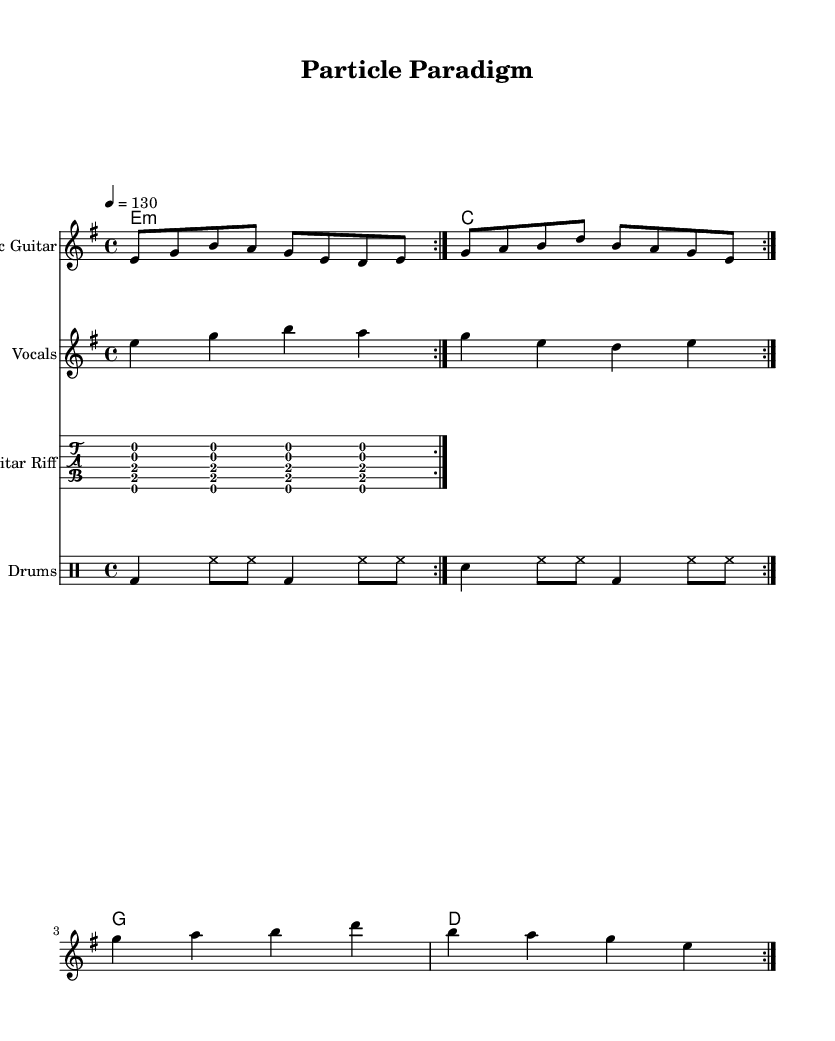What is the key signature of this music? The key signature is E minor, which has one sharp (F#). This can be determined by looking at the key indication at the beginning of the score.
Answer: E minor What is the time signature of this music? The time signature is 4/4, indicated at the beginning of the score. This means there are four beats per measure and the quarter note gets one beat.
Answer: 4/4 What is the tempo marking for this piece? The tempo marking is 130 beats per minute, represented numerically in the section where tempo is specified. This shows the speed at which the piece should be played.
Answer: 130 How many measures are repeated in the guitar riff? The guitar riff is indicated to repeat two times, as shown by the "repeat volta 2" marking above the staff. This signifies that the section should be played twice.
Answer: 2 What is the first chord played in the piece? The first chord played is E minor, which can be identified in the chord names section at the beginning of the score. This indicates the harmonic foundation of the piece.
Answer: E minor What instrument is specified for the drum pattern? The instrument specified for the drum pattern is Drums, as indicated in the label of the DrumStaff in the score. This shows which instrument the drum part is assigned to.
Answer: Drums What is the vocal pattern's note value for the first measure? The vocal pattern's note value for the first measure consists of one half note and two quarter notes, making it a total of four beats for that measure. The rhythm is indicated in the vocal staff section.
Answer: One half note and two quarter notes 